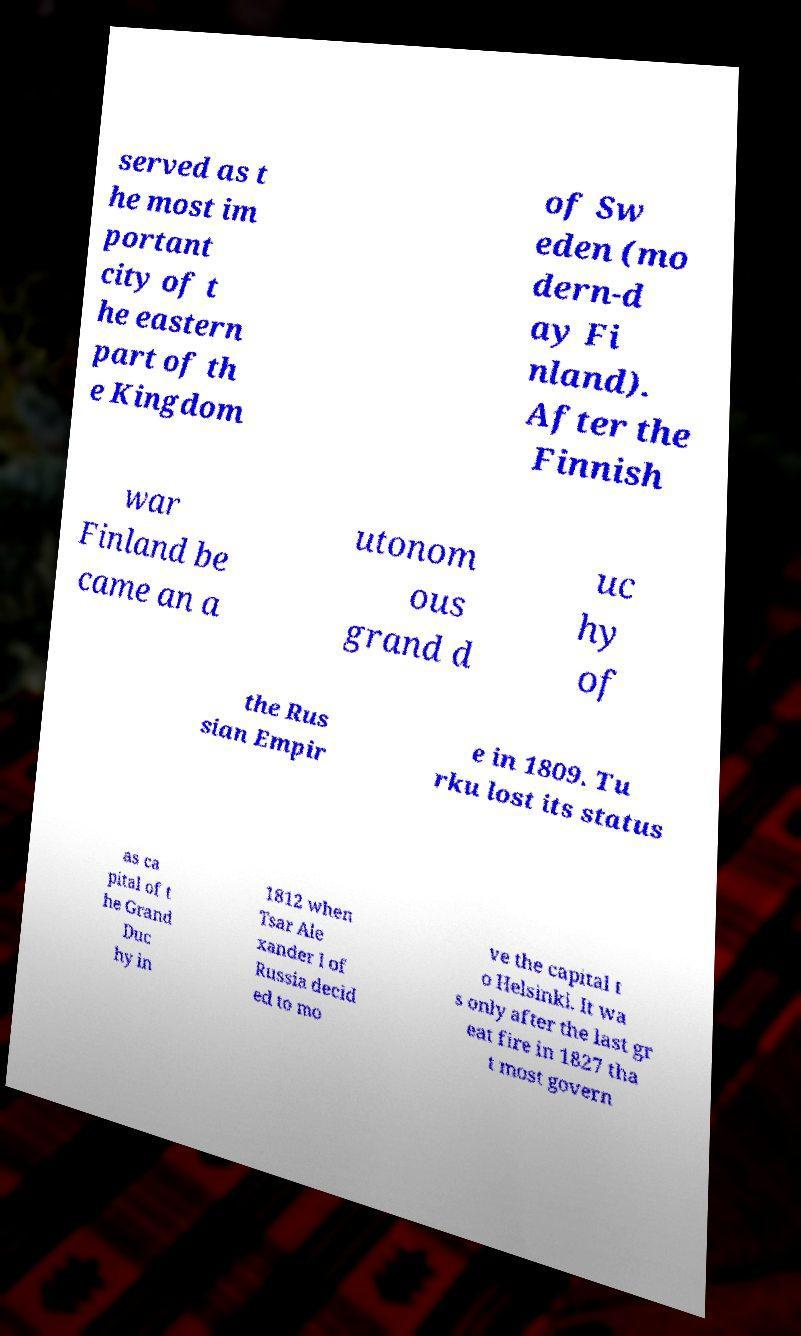I need the written content from this picture converted into text. Can you do that? served as t he most im portant city of t he eastern part of th e Kingdom of Sw eden (mo dern-d ay Fi nland). After the Finnish war Finland be came an a utonom ous grand d uc hy of the Rus sian Empir e in 1809. Tu rku lost its status as ca pital of t he Grand Duc hy in 1812 when Tsar Ale xander I of Russia decid ed to mo ve the capital t o Helsinki. It wa s only after the last gr eat fire in 1827 tha t most govern 